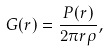Convert formula to latex. <formula><loc_0><loc_0><loc_500><loc_500>G ( r ) = \frac { P ( r ) } { 2 \pi r \rho } ,</formula> 